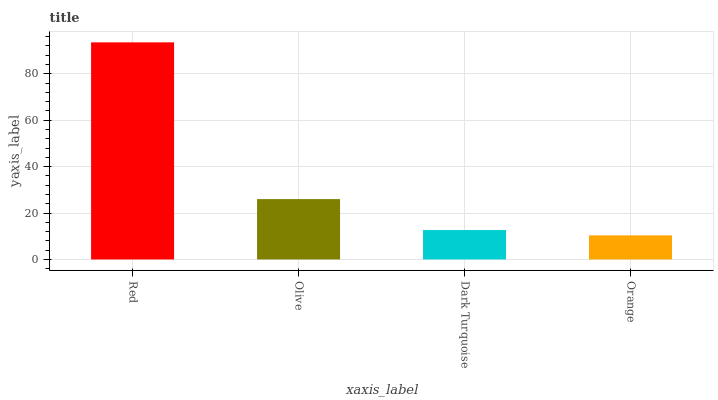Is Orange the minimum?
Answer yes or no. Yes. Is Red the maximum?
Answer yes or no. Yes. Is Olive the minimum?
Answer yes or no. No. Is Olive the maximum?
Answer yes or no. No. Is Red greater than Olive?
Answer yes or no. Yes. Is Olive less than Red?
Answer yes or no. Yes. Is Olive greater than Red?
Answer yes or no. No. Is Red less than Olive?
Answer yes or no. No. Is Olive the high median?
Answer yes or no. Yes. Is Dark Turquoise the low median?
Answer yes or no. Yes. Is Orange the high median?
Answer yes or no. No. Is Olive the low median?
Answer yes or no. No. 